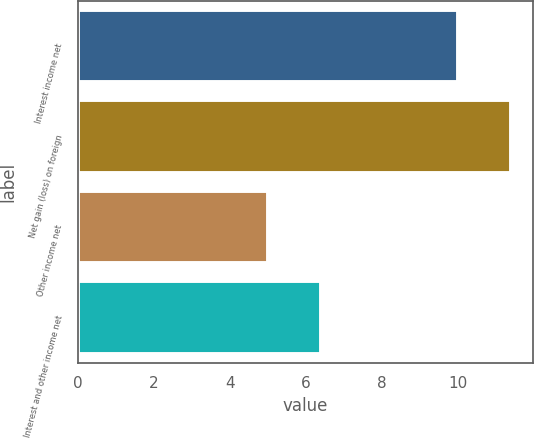<chart> <loc_0><loc_0><loc_500><loc_500><bar_chart><fcel>Interest income net<fcel>Net gain (loss) on foreign<fcel>Other income net<fcel>Interest and other income net<nl><fcel>10<fcel>11.4<fcel>5<fcel>6.4<nl></chart> 